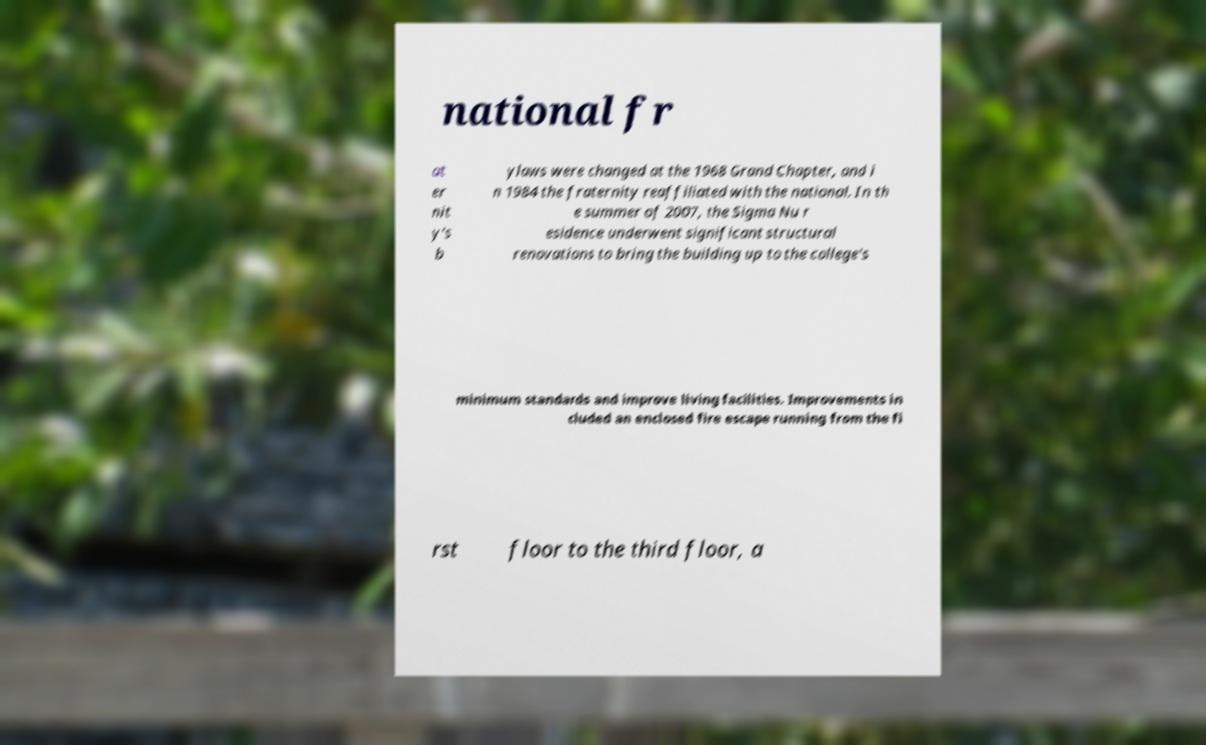Please read and relay the text visible in this image. What does it say? national fr at er nit y's b ylaws were changed at the 1968 Grand Chapter, and i n 1984 the fraternity reaffiliated with the national. In th e summer of 2007, the Sigma Nu r esidence underwent significant structural renovations to bring the building up to the college's minimum standards and improve living facilities. Improvements in cluded an enclosed fire escape running from the fi rst floor to the third floor, a 